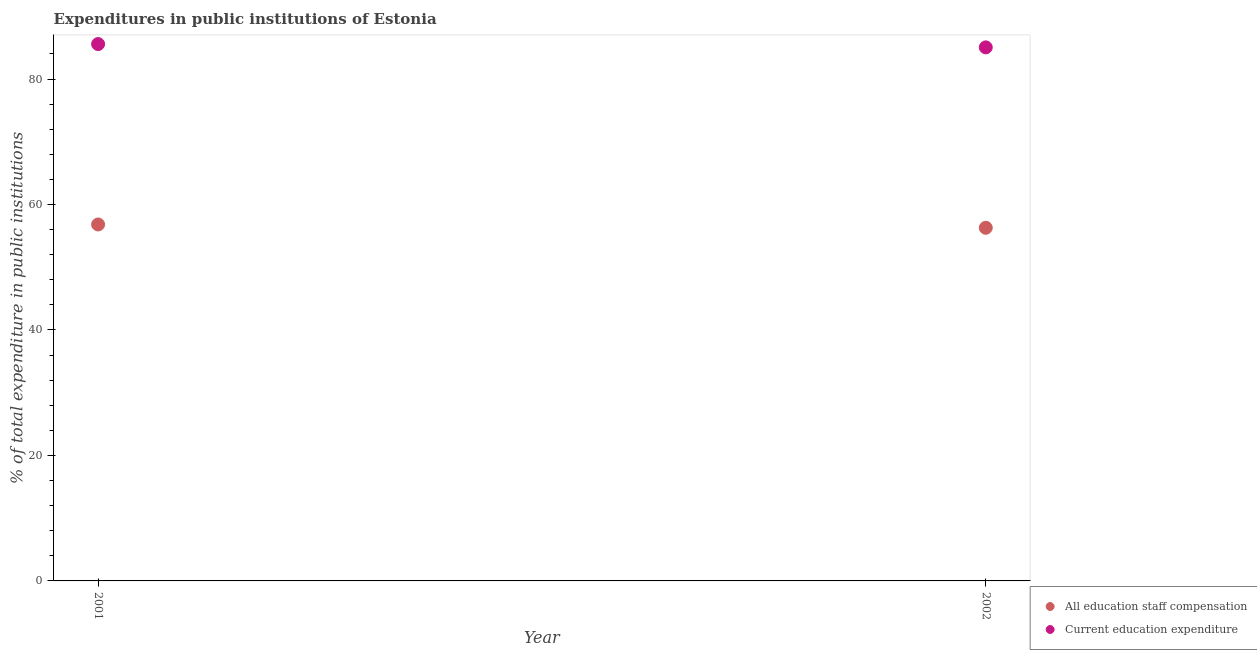What is the expenditure in staff compensation in 2002?
Your answer should be compact. 56.29. Across all years, what is the maximum expenditure in staff compensation?
Ensure brevity in your answer.  56.81. Across all years, what is the minimum expenditure in education?
Offer a very short reply. 85.04. What is the total expenditure in education in the graph?
Provide a short and direct response. 170.61. What is the difference between the expenditure in education in 2001 and that in 2002?
Your response must be concise. 0.53. What is the difference between the expenditure in education in 2001 and the expenditure in staff compensation in 2002?
Offer a very short reply. 29.28. What is the average expenditure in staff compensation per year?
Your response must be concise. 56.55. In the year 2001, what is the difference between the expenditure in education and expenditure in staff compensation?
Provide a short and direct response. 28.76. What is the ratio of the expenditure in education in 2001 to that in 2002?
Offer a terse response. 1.01. Does the expenditure in staff compensation monotonically increase over the years?
Your response must be concise. No. Is the expenditure in education strictly less than the expenditure in staff compensation over the years?
Provide a short and direct response. No. Are the values on the major ticks of Y-axis written in scientific E-notation?
Provide a succinct answer. No. Does the graph contain grids?
Offer a very short reply. No. Where does the legend appear in the graph?
Make the answer very short. Bottom right. What is the title of the graph?
Provide a short and direct response. Expenditures in public institutions of Estonia. Does "Chemicals" appear as one of the legend labels in the graph?
Make the answer very short. No. What is the label or title of the Y-axis?
Provide a succinct answer. % of total expenditure in public institutions. What is the % of total expenditure in public institutions in All education staff compensation in 2001?
Make the answer very short. 56.81. What is the % of total expenditure in public institutions in Current education expenditure in 2001?
Give a very brief answer. 85.57. What is the % of total expenditure in public institutions of All education staff compensation in 2002?
Give a very brief answer. 56.29. What is the % of total expenditure in public institutions of Current education expenditure in 2002?
Give a very brief answer. 85.04. Across all years, what is the maximum % of total expenditure in public institutions of All education staff compensation?
Give a very brief answer. 56.81. Across all years, what is the maximum % of total expenditure in public institutions of Current education expenditure?
Offer a very short reply. 85.57. Across all years, what is the minimum % of total expenditure in public institutions of All education staff compensation?
Give a very brief answer. 56.29. Across all years, what is the minimum % of total expenditure in public institutions in Current education expenditure?
Keep it short and to the point. 85.04. What is the total % of total expenditure in public institutions in All education staff compensation in the graph?
Your answer should be very brief. 113.1. What is the total % of total expenditure in public institutions of Current education expenditure in the graph?
Provide a short and direct response. 170.61. What is the difference between the % of total expenditure in public institutions of All education staff compensation in 2001 and that in 2002?
Your answer should be very brief. 0.53. What is the difference between the % of total expenditure in public institutions of Current education expenditure in 2001 and that in 2002?
Make the answer very short. 0.53. What is the difference between the % of total expenditure in public institutions of All education staff compensation in 2001 and the % of total expenditure in public institutions of Current education expenditure in 2002?
Offer a very short reply. -28.23. What is the average % of total expenditure in public institutions in All education staff compensation per year?
Keep it short and to the point. 56.55. What is the average % of total expenditure in public institutions of Current education expenditure per year?
Your response must be concise. 85.31. In the year 2001, what is the difference between the % of total expenditure in public institutions of All education staff compensation and % of total expenditure in public institutions of Current education expenditure?
Your answer should be very brief. -28.76. In the year 2002, what is the difference between the % of total expenditure in public institutions of All education staff compensation and % of total expenditure in public institutions of Current education expenditure?
Offer a terse response. -28.75. What is the ratio of the % of total expenditure in public institutions in All education staff compensation in 2001 to that in 2002?
Make the answer very short. 1.01. What is the ratio of the % of total expenditure in public institutions of Current education expenditure in 2001 to that in 2002?
Your answer should be very brief. 1.01. What is the difference between the highest and the second highest % of total expenditure in public institutions of All education staff compensation?
Offer a terse response. 0.53. What is the difference between the highest and the second highest % of total expenditure in public institutions of Current education expenditure?
Keep it short and to the point. 0.53. What is the difference between the highest and the lowest % of total expenditure in public institutions in All education staff compensation?
Keep it short and to the point. 0.53. What is the difference between the highest and the lowest % of total expenditure in public institutions in Current education expenditure?
Provide a short and direct response. 0.53. 